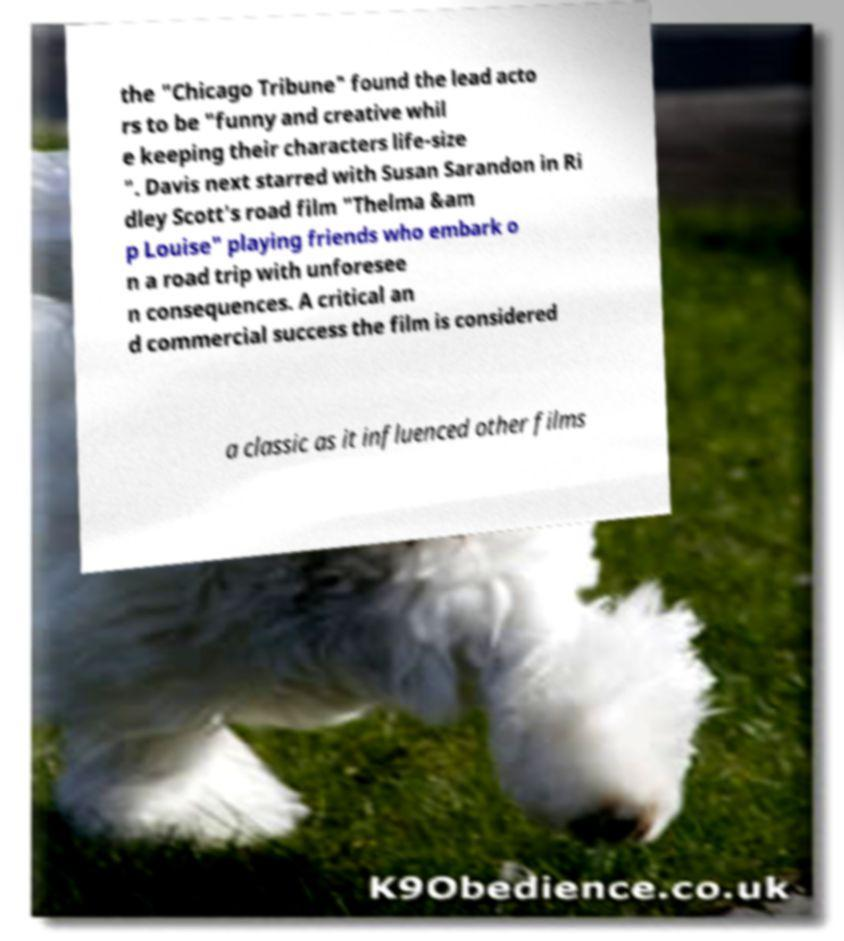What messages or text are displayed in this image? I need them in a readable, typed format. the "Chicago Tribune" found the lead acto rs to be "funny and creative whil e keeping their characters life-size ". Davis next starred with Susan Sarandon in Ri dley Scott's road film "Thelma &am p Louise" playing friends who embark o n a road trip with unforesee n consequences. A critical an d commercial success the film is considered a classic as it influenced other films 